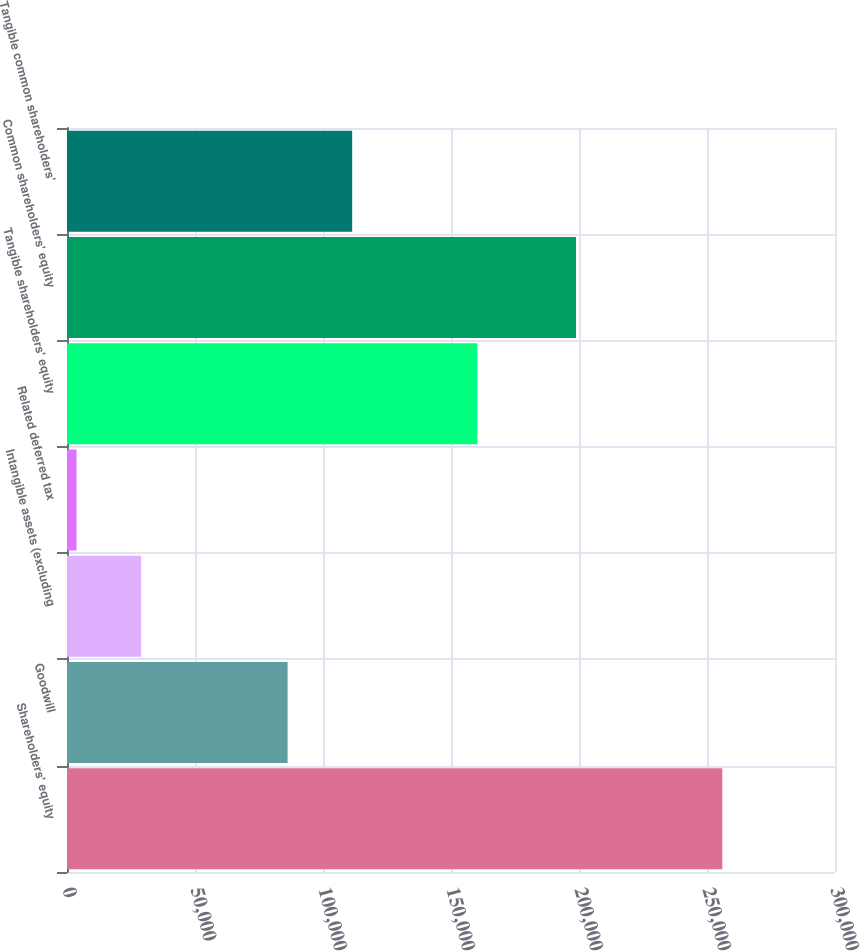<chart> <loc_0><loc_0><loc_500><loc_500><bar_chart><fcel>Shareholders' equity<fcel>Goodwill<fcel>Intangible assets (excluding<fcel>Related deferred tax<fcel>Tangible shareholders' equity<fcel>Common shareholders' equity<fcel>Tangible common shareholders'<nl><fcel>255983<fcel>86170<fcel>28950.8<fcel>3725<fcel>160315<fcel>198843<fcel>111396<nl></chart> 